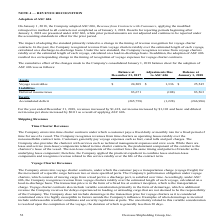According to Overseas Shipholding Group's financial document, How much did revenues increased for the year ended December 31, 2018 as a result of applying ASC 606? According to the financial document, $1,418. The relevant text states: "ear ended December 31, 2018, revenues increased by $1,418, net income increased by $1,101 and basic and diluted net income per share increased by $0.01 as a..." Also, How much did net income increased for the year ended December 31, 2018 as a result of applying ASC 606? According to the financial document, $1,101. The relevant text states: "enues increased by $1,418, net income increased by $1,101 and basic and diluted net income per share increased by $0.01 as a result of applying ASC 606...." Also, How much did basic and diluted income increased for the year ended December 31, 2018 as a result of applying ASC 606? According to the financial document, $0.01. The relevant text states: "asic and diluted net income per share increased by $0.01 as a result of applying ASC 606...." Also, can you calculate: What is the change in Assets: Voyage receivables from Balance at December 31, 2017 to January 1, 2018? Based on the calculation: 25,545-24,209, the result is 1336. This is based on the information: "Voyage receivables $ 24,209 $ 1,336 $ 25,545 Voyage receivables $ 24,209 $ 1,336 $ 25,545..." The key data points involved are: 24,209, 25,545. Also, can you calculate: What is the change in Liabilities: Deferred income taxes from Balance at December 31, 2017 to January 1, 2018? Based on the calculation: 83,563-83,671, the result is -108. This is based on the information: "Deferred income taxes 83,671 (108) 83,563 Deferred income taxes 83,671 (108) 83,563..." The key data points involved are: 83,563, 83,671. Also, can you calculate: What is the average Assets: Voyage receivables for Balance at December 31, 2017 to January 1, 2018? To answer this question, I need to perform calculations using the financial data. The calculation is: (25,545+24,209) / 2, which equals 24877. This is based on the information: "Voyage receivables $ 24,209 $ 1,336 $ 25,545 Voyage receivables $ 24,209 $ 1,336 $ 25,545..." The key data points involved are: 24,209, 25,545. 